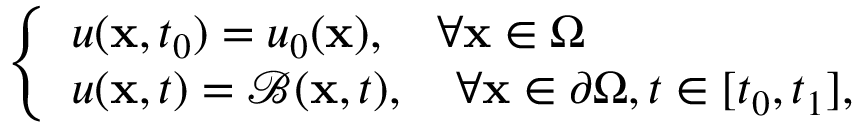Convert formula to latex. <formula><loc_0><loc_0><loc_500><loc_500>\begin{array} { r } { \left \{ \begin{array} { l l } { u ( x , t _ { 0 } ) = u _ { 0 } ( x ) , \quad \forall x \in \Omega } \\ { u ( x , t ) = \mathcal { B } ( x , t ) , \quad \forall x \in \partial \Omega , t \in [ t _ { 0 } , t _ { 1 } ] , } \end{array} } \end{array}</formula> 